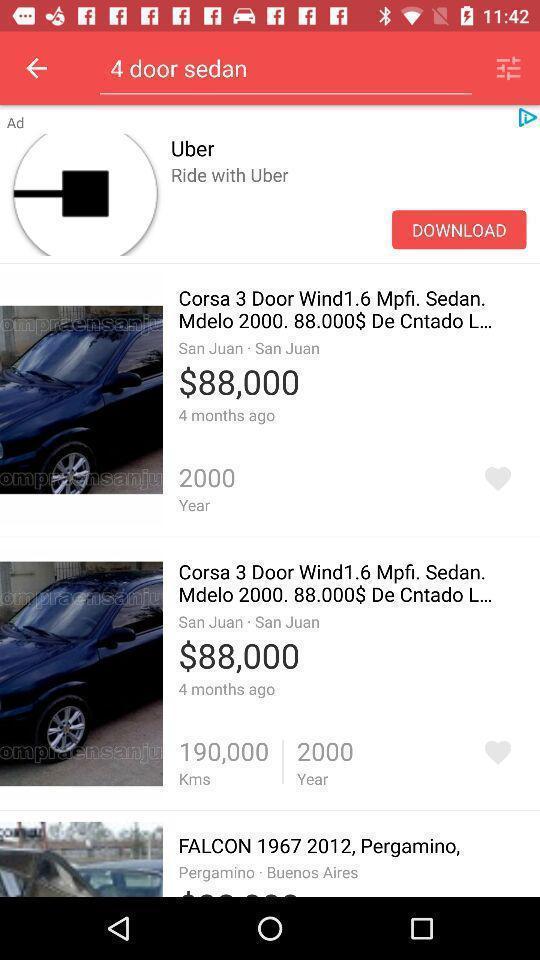Provide a description of this screenshot. Screen displaying multiple vehicles information with price. 